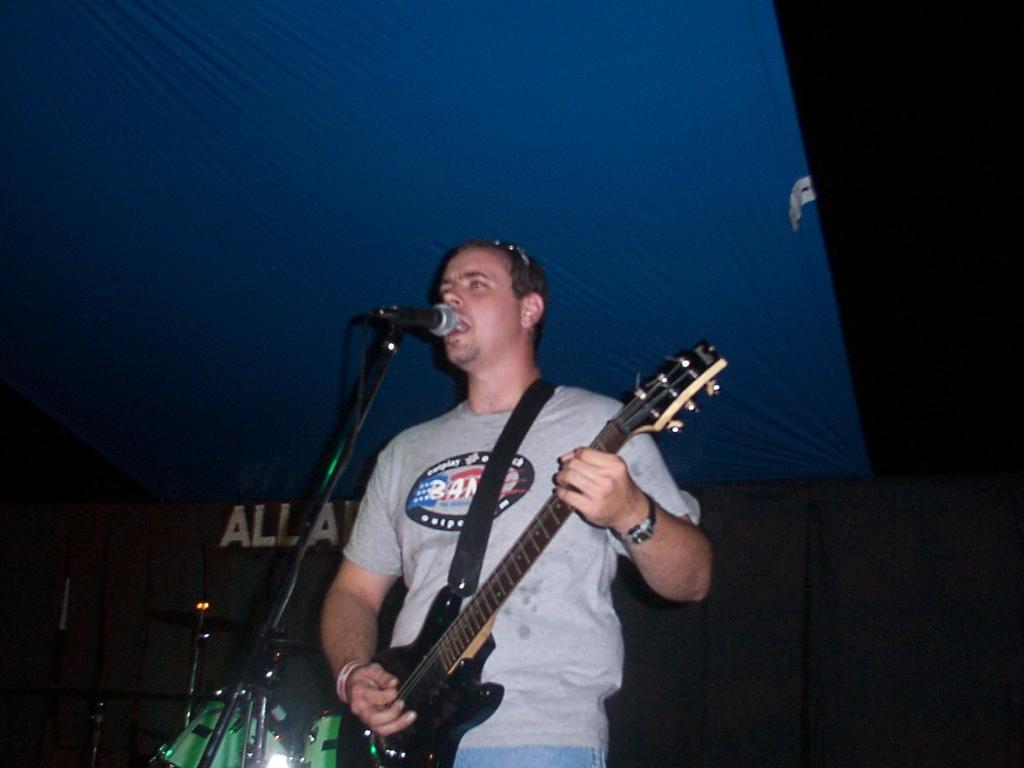How would you summarize this image in a sentence or two? There is a man singing on the mike and he is playing guitar. There are musical instruments. Here we can see a cloth and there is a dark background. 